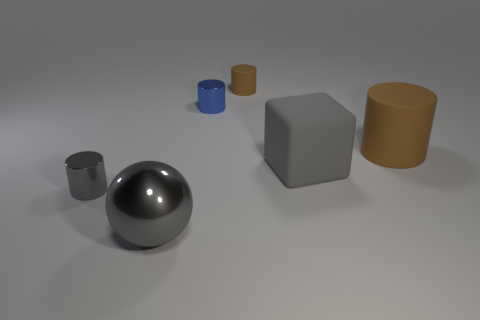How many brown cylinders must be subtracted to get 1 brown cylinders? 1 Add 2 large matte things. How many objects exist? 8 Subtract all spheres. How many objects are left? 5 Subtract 1 gray cubes. How many objects are left? 5 Subtract all large balls. Subtract all blue metal things. How many objects are left? 4 Add 6 shiny things. How many shiny things are left? 9 Add 3 tiny blue shiny things. How many tiny blue shiny things exist? 4 